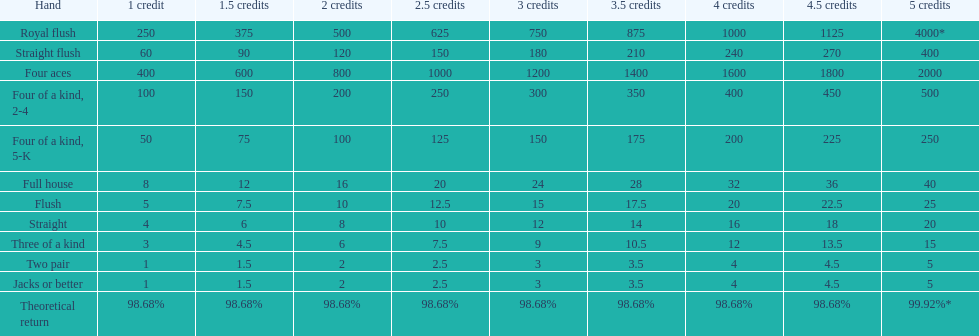Which is a higher standing hand: a straight or a flush? Flush. 